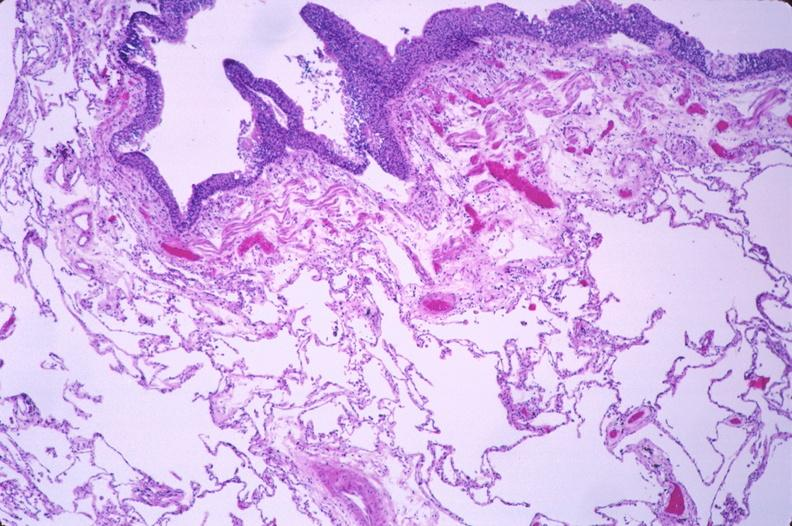what does this image show?
Answer the question using a single word or phrase. Lung 